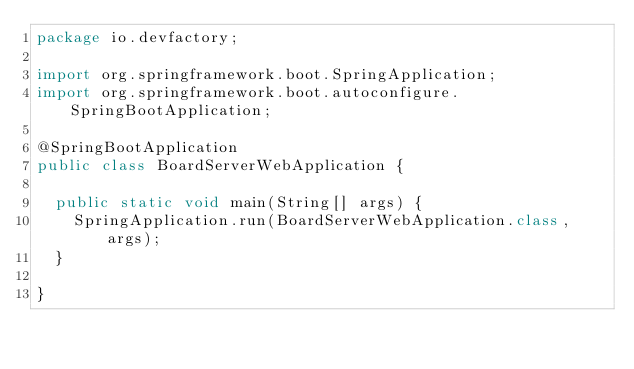<code> <loc_0><loc_0><loc_500><loc_500><_Java_>package io.devfactory;

import org.springframework.boot.SpringApplication;
import org.springframework.boot.autoconfigure.SpringBootApplication;

@SpringBootApplication
public class BoardServerWebApplication {

  public static void main(String[] args) {
    SpringApplication.run(BoardServerWebApplication.class, args);
  }

}
</code> 